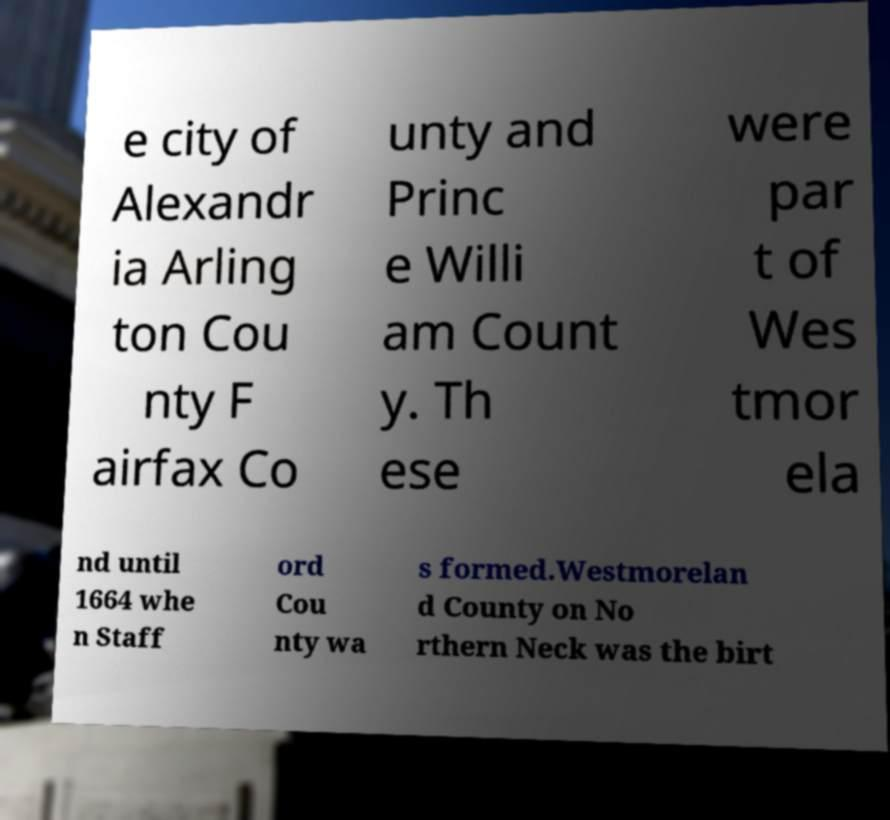Please identify and transcribe the text found in this image. e city of Alexandr ia Arling ton Cou nty F airfax Co unty and Princ e Willi am Count y. Th ese were par t of Wes tmor ela nd until 1664 whe n Staff ord Cou nty wa s formed.Westmorelan d County on No rthern Neck was the birt 